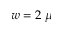<formula> <loc_0><loc_0><loc_500><loc_500>w = 2 \mu</formula> 